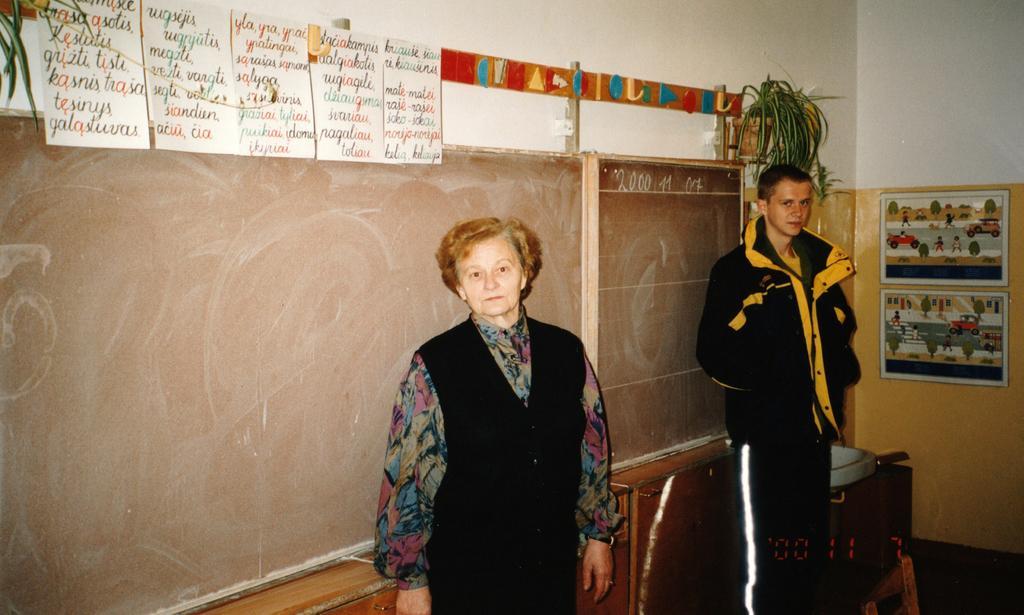Could you give a brief overview of what you see in this image? In this image we can see a man and a woman standing and behind these two people we can see the boards and we can also see the text written on the papers which are attached to the wall. We can also see the flower pots and frames. In the bottom right corner we can see the numbers. 